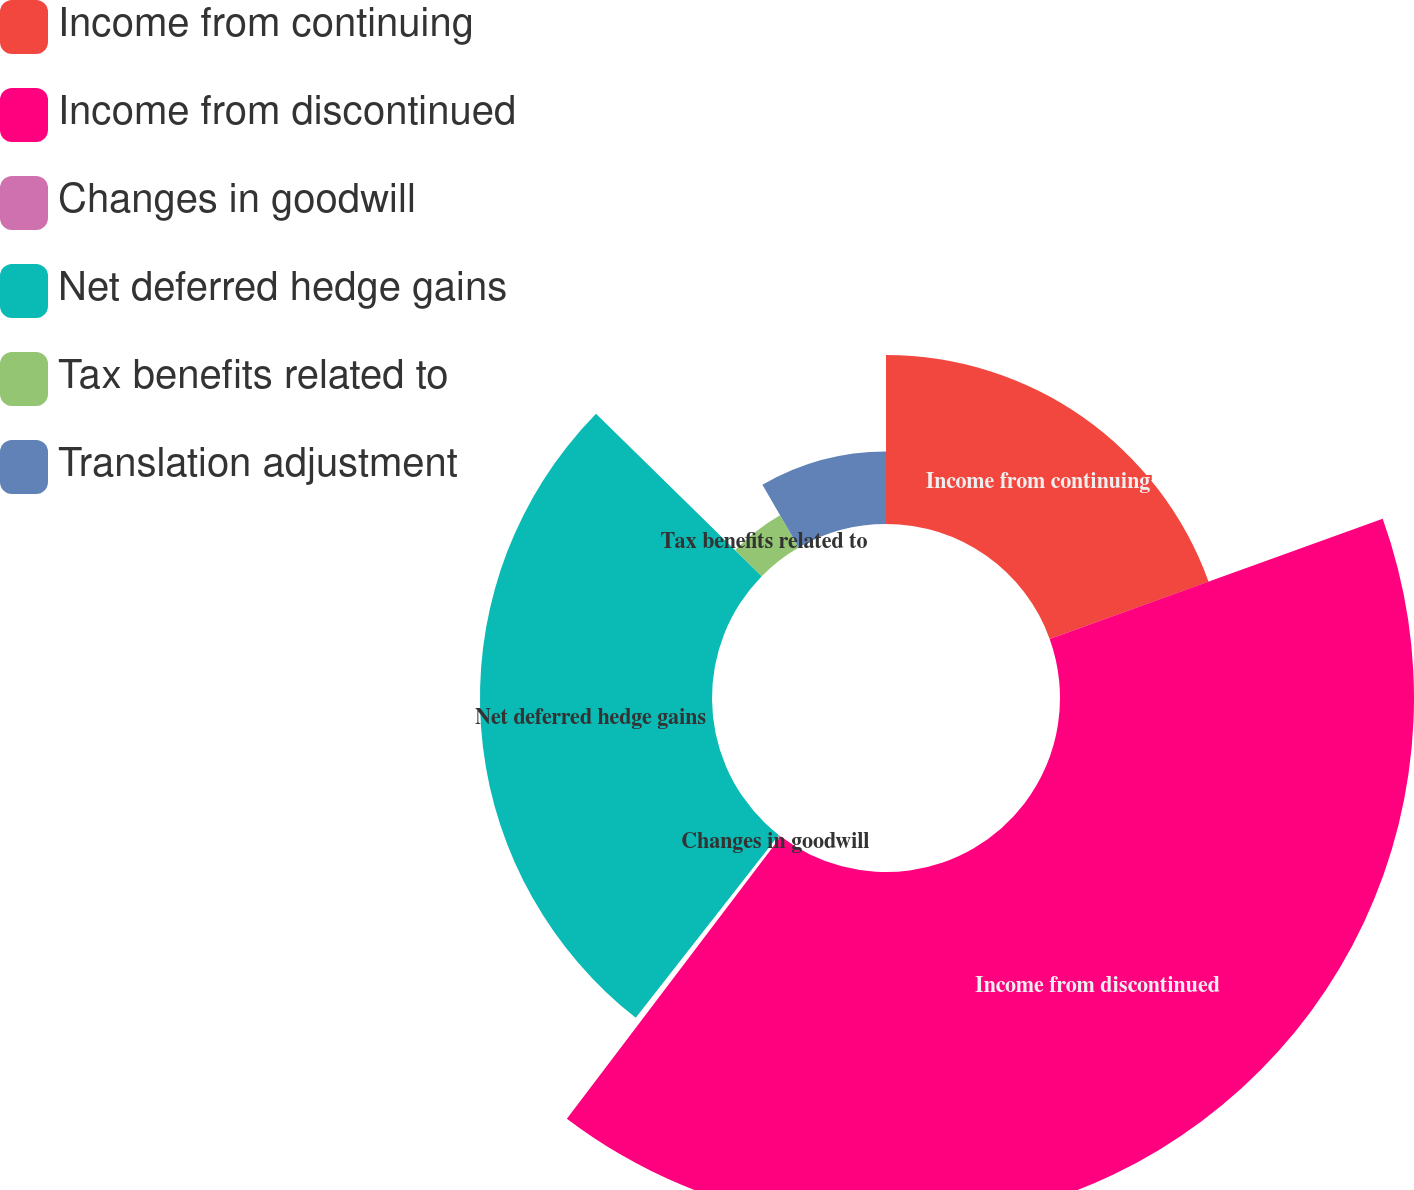Convert chart to OTSL. <chart><loc_0><loc_0><loc_500><loc_500><pie_chart><fcel>Income from continuing<fcel>Income from discontinued<fcel>Changes in goodwill<fcel>Net deferred hedge gains<fcel>Tax benefits related to<fcel>Translation adjustment<nl><fcel>19.49%<fcel>40.84%<fcel>0.24%<fcel>26.77%<fcel>4.3%<fcel>8.36%<nl></chart> 